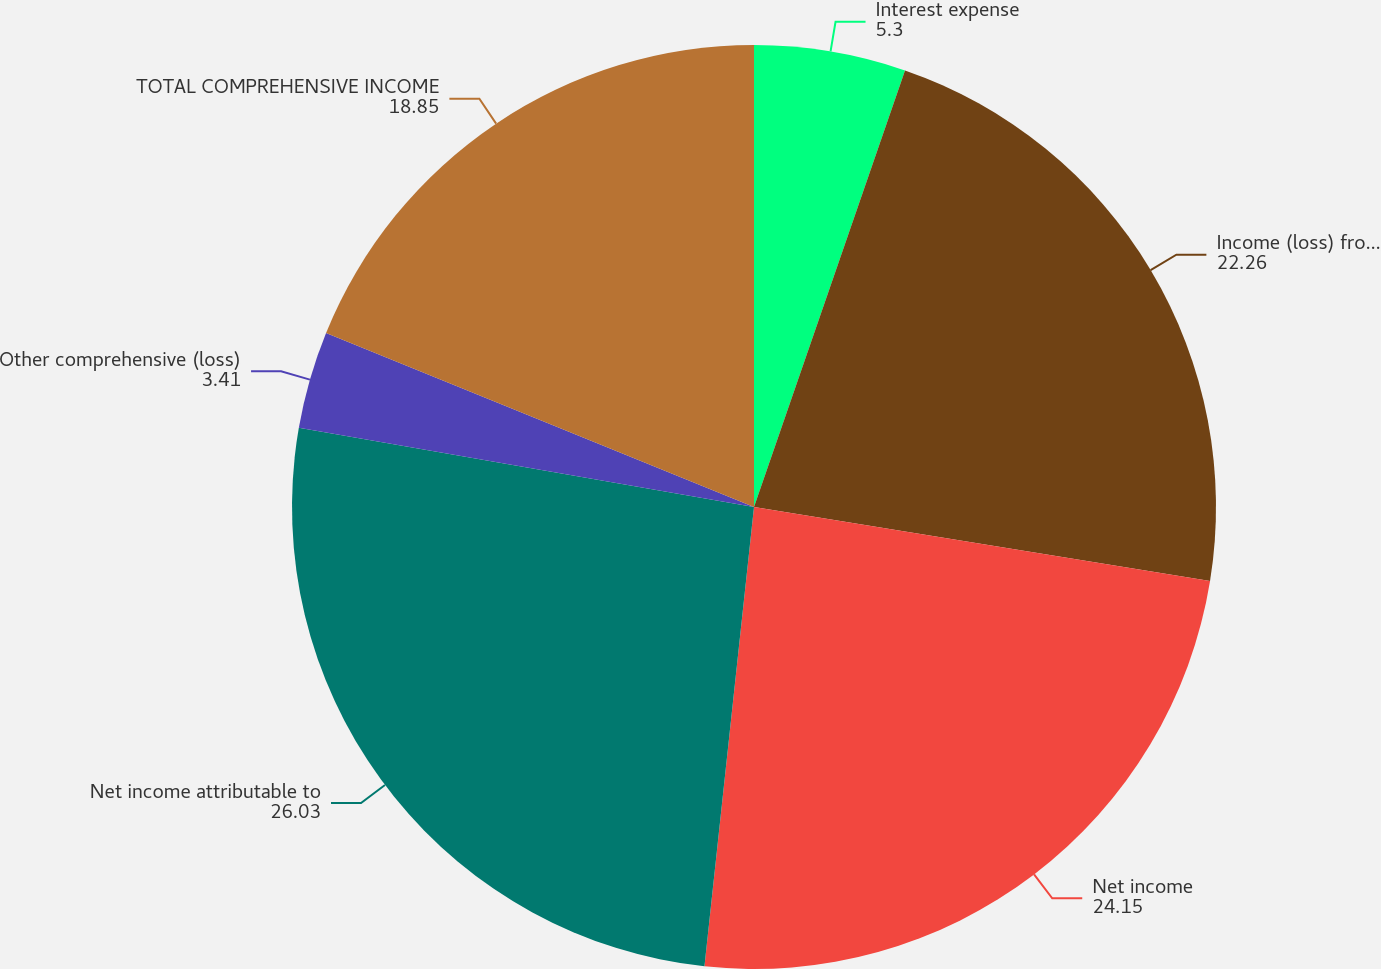Convert chart to OTSL. <chart><loc_0><loc_0><loc_500><loc_500><pie_chart><fcel>Interest expense<fcel>Income (loss) from operations<fcel>Net income<fcel>Net income attributable to<fcel>Other comprehensive (loss)<fcel>TOTAL COMPREHENSIVE INCOME<nl><fcel>5.3%<fcel>22.26%<fcel>24.15%<fcel>26.03%<fcel>3.41%<fcel>18.85%<nl></chart> 